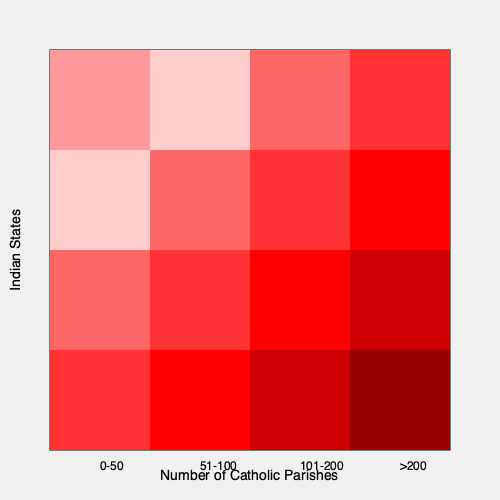Based on the choropleth map shown, which quadrant of India appears to have the highest concentration of Catholic parishes? To answer this question, we need to analyze the choropleth map systematically:

1. The map is divided into a 4x4 grid, representing different regions of India.
2. The color intensity increases from light pink to dark red, indicating a higher number of Catholic parishes.
3. The legend shows that darker colors represent more parishes:
   - Lightest pink: 0-50 parishes
   - Light pink: 51-100 parishes
   - Medium red: 101-200 parishes
   - Darkest red: >200 parishes
4. Analyzing each quadrant:
   - Northwest (top-left): Mostly light pink, indicating fewer parishes
   - Northeast (top-right): Mix of medium to dark red, suggesting more parishes
   - Southwest (bottom-left): Mix of medium to dark red, similar to Northeast
   - Southeast (bottom-right): Consistently dark red, indicating the highest concentration of parishes

5. The Southeast quadrant (bottom-right) has the darkest red colors across all its cells, representing the highest number of parishes (>200) in each state within this region.

Therefore, based on this choropleth map, the Southeast quadrant of India appears to have the highest concentration of Catholic parishes.
Answer: Southeast quadrant 